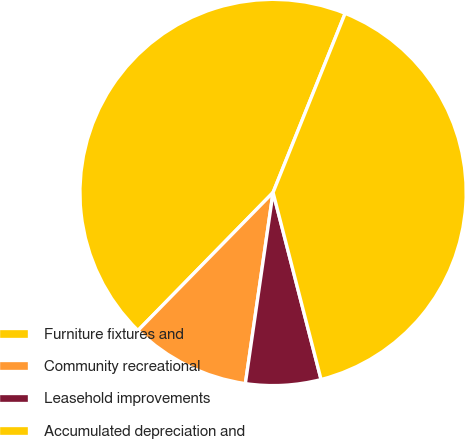Convert chart to OTSL. <chart><loc_0><loc_0><loc_500><loc_500><pie_chart><fcel>Furniture fixtures and<fcel>Community recreational<fcel>Leasehold improvements<fcel>Accumulated depreciation and<nl><fcel>43.76%<fcel>10.04%<fcel>6.29%<fcel>39.91%<nl></chart> 